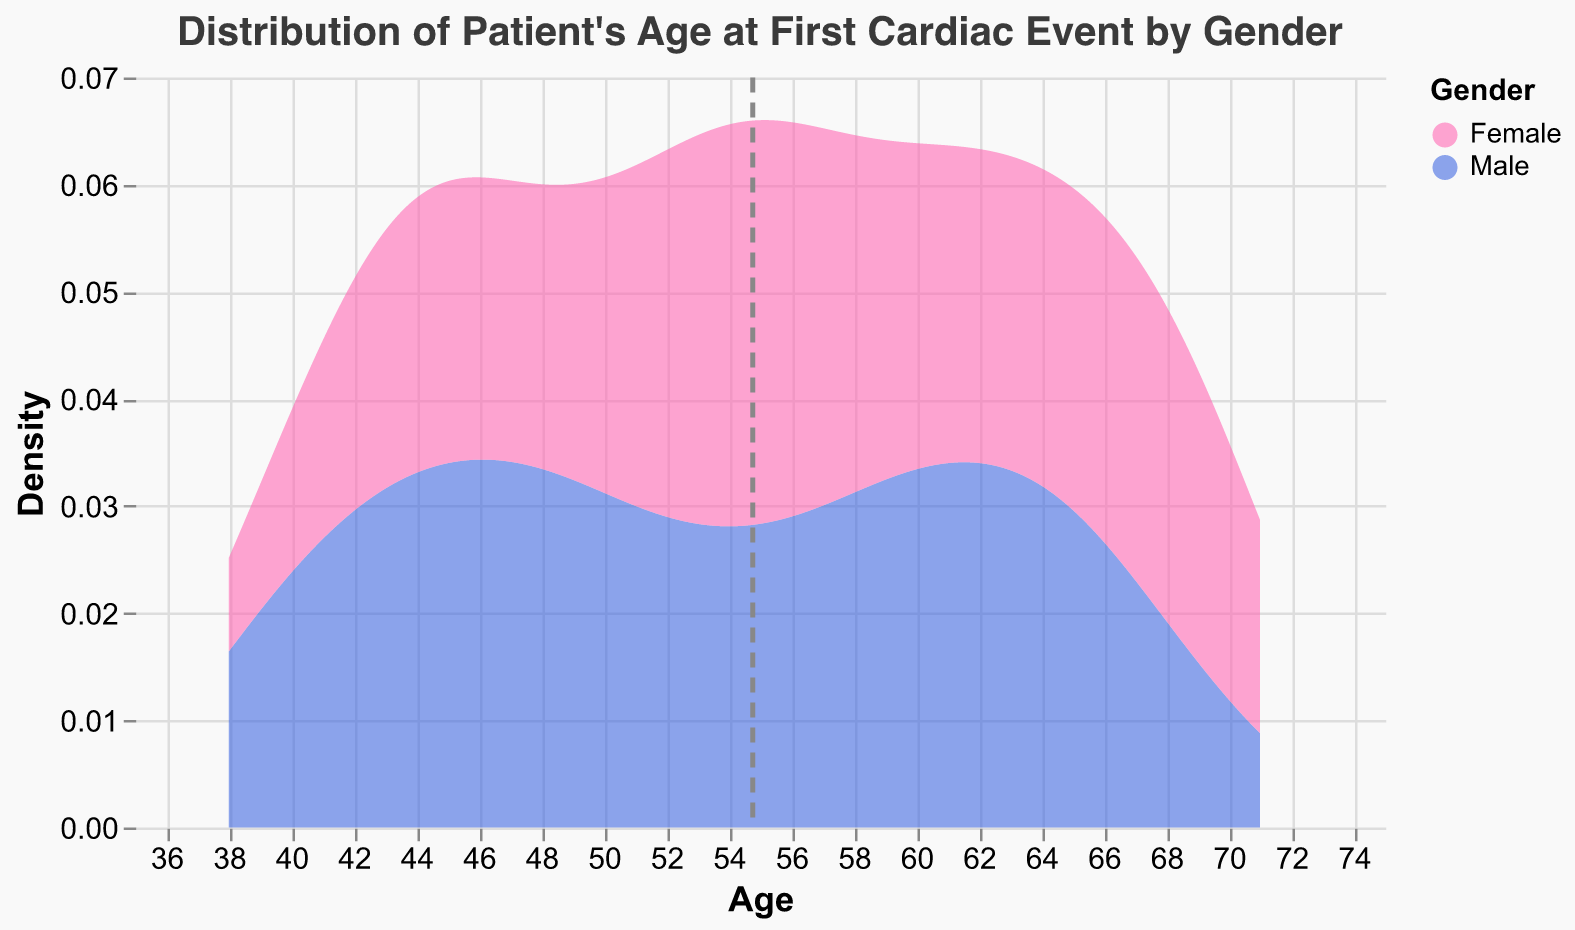What is the title of the plot? The title is displayed at the top of the plot, indicating its purpose or subject.
Answer: Distribution of Patient's Age at First Cardiac Event by Gender What are the colors representing the different genders in the plot? The colors are used to differentiate between the two genders in the density plot. Pink represents Female and blue represents Male.
Answer: Pink for Female, Blue for Male What is the age range covered in the plot? The x-axis shows the variable "Age," and its values range from the minimum to the maximum age value in the dataset.
Answer: 38 to 71 Where is the peak of the density for males? Find the highest point in the density curve for the Male category. The peak represents the age where the density value is the highest.
Answer: Around age 45 Where is the peak of the density for females? Look for the highest point in the density curve for the Female category. The peak represents the age where the density value is the highest.
Answer: Around age 55 Which gender has a higher mean age at the first cardiac event? The dashed vertical line represents the mean age for both genders. Compare the location of the dashed lines for each gender.
Answer: Female What is the highest density value for the female distribution? Find the highest point on the density curve for females. The y-axis shows the density values.
Answer: Approximately 0.03 Which gender shows a broader age range for the first cardiac event? Look at the spread of the density curves for both genders. The broader the curve, the more spread out the ages.
Answer: Male Does any gender have more than one peak (bimodal distribution) in the density plot? Check the density curves for any multiple peaks. This indicates that there are two common ages when cardiac events occur for that gender.
Answer: No How does the density plot help in understanding the distribution of the first cardiac event by age and gender? The density plot shows the continuous probability distribution of the age at which the first cardiac event occurs for each gender. Peaks indicate the most common ages, and the spread shows variability.
Answer: It shows the distribution of common ages and variability for each gender 